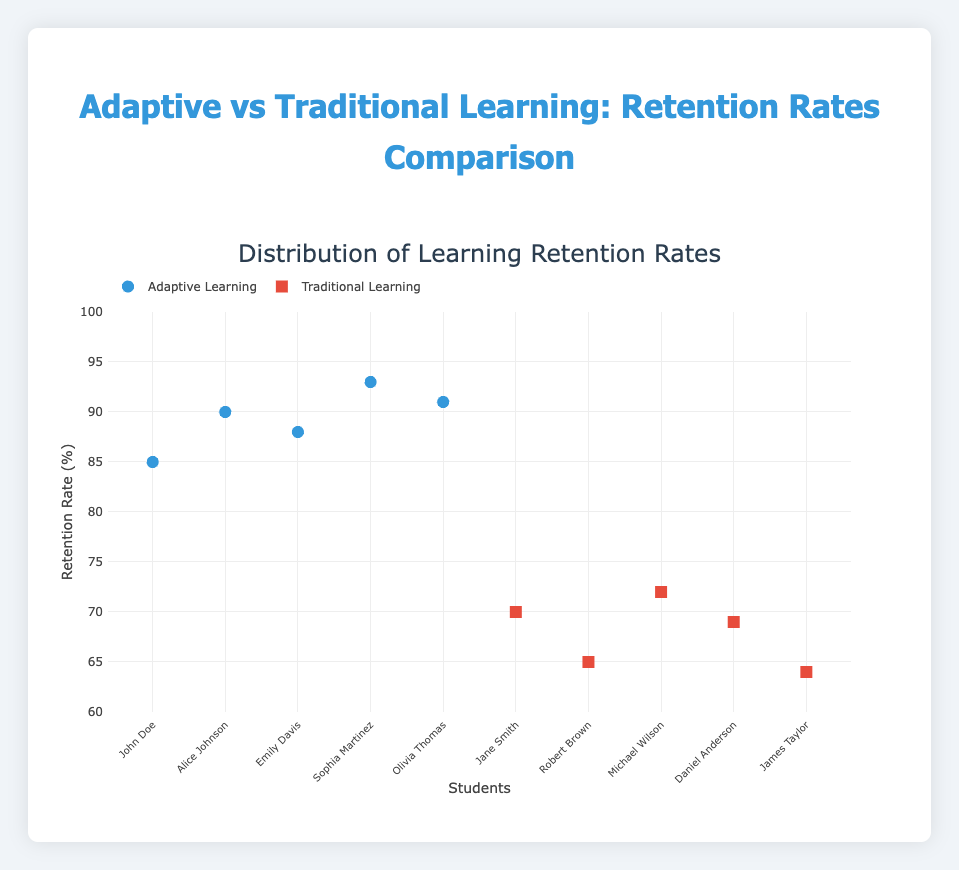What are the two types of learning methods compared in the figure? The scatter plot shows data points labeled under two categories. One is "Adaptive Learning" represented by circular markers, and the other is "Traditional Learning" represented by square markers.
Answer: Adaptive Learning and Traditional Learning How many students were evaluated for each learning method? By counting the data points for each method, it appears there are five students under "Adaptive Learning" and five under "Traditional Learning."
Answer: 5 for each method What is the retention rate range for Adaptive Learning? The retention rates for Adaptive Learning range from the lowest value of 85 to the highest value of 93, as indicated by the vertical position of the blue circular markers on the y-axis.
Answer: 85 to 93 Which student has the highest retention rate, and which learning method do they use? By examining the y-axis values, Sophia Martinez has the highest retention rate of 93, and she is under the "Adaptive Learning" method.
Answer: Sophia Martinez, Adaptive Learning What is the average retention rate for Traditional Learning? The retention rates for Traditional Learning students are 70, 65, 72, 69, and 64. By summing these and dividing by the number of students (5): (70 + 65 + 72 + 69 + 64) / 5 = 340 / 5 = 68.
Answer: 68 Compare the retention rate of John Doe and Jane Smith. Which method is more effective for these students? John Doe (Adaptive Learning) has a retention rate of 85, while Jane Smith (Traditional Learning) has a retention rate of 70. Therefore, Adaptive Learning is more effective for these students.
Answer: Adaptive Learning Which student has the lowest retention rate, and what is their learning method? From the scatter plot, the lowest retention rate is 64, which belongs to James Taylor under the "Traditional Learning" method.
Answer: James Taylor, Traditional Learning Can you identify if there’s an overall trend between the two learning methods based on retention rates? By inspecting the scatter plot, retention rates for Adaptive Learning (85 to 93) are generally higher compared to Traditional Learning (64 to 72), indicating that Adaptive Learning often results in higher retention rates.
Answer: Adaptive Learning has higher retention rates What is the difference in retention rates between the highest and the lowest among all students? The highest retention rate is 93 (Sophia Martinez, Adaptive Learning) and the lowest is 64 (James Taylor, Traditional Learning). The difference is 93 - 64 = 29.
Answer: 29 